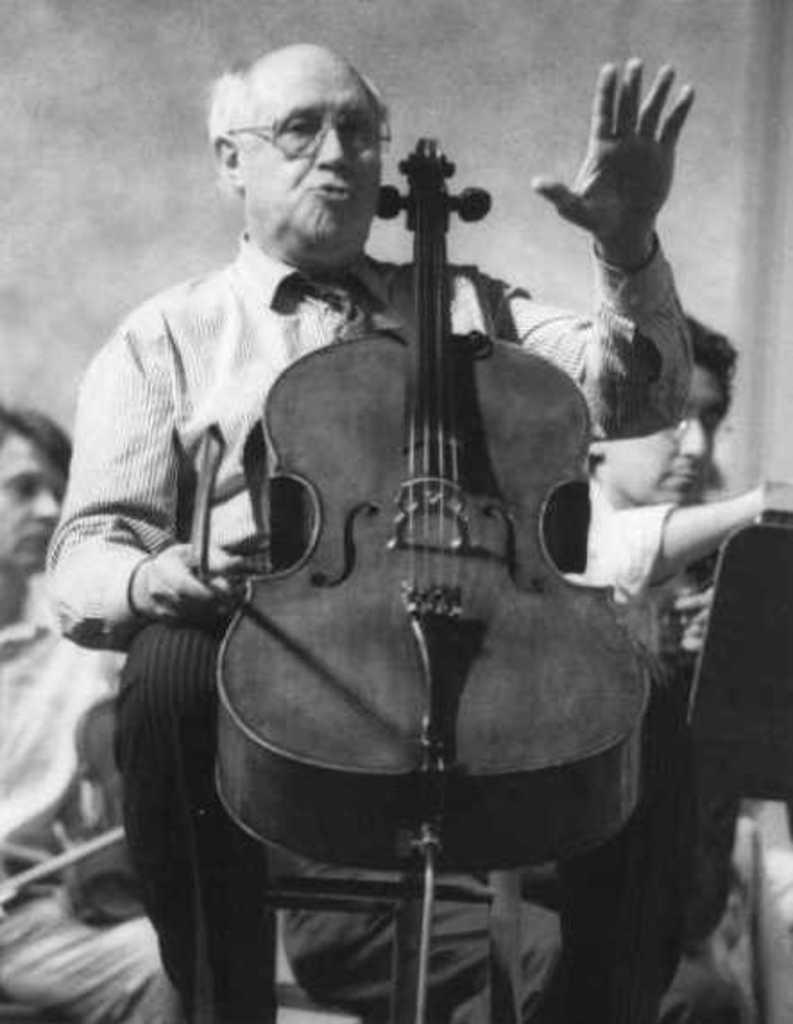What is the main subject of the image? There is a man in the image. What is the man doing in the image? The man is sitting. What is the man holding in the image? The man is holding a musical instrument. What type of cattle can be seen grazing in the background of the image? There is no cattle present in the image; it only features a man sitting and holding a musical instrument. 